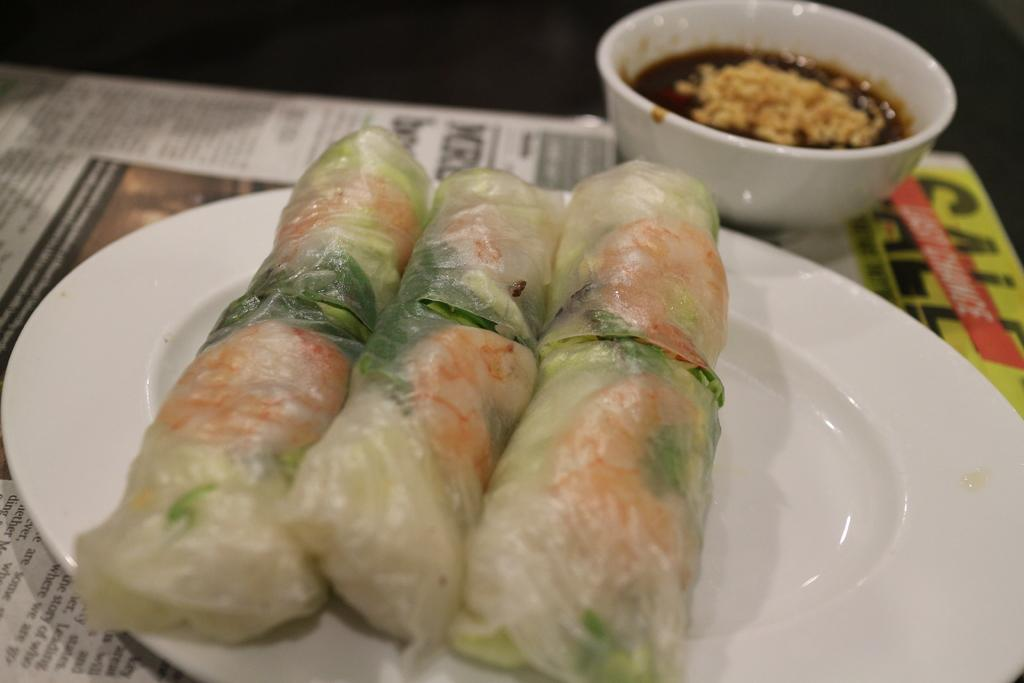What is the main food item wrapped in a cover on the plate? The facts do not specify the type of food item wrapped in a cover on the plate. What type of food is in the bowl? The facts do not specify the type of food in the bowl. What is the plate and bowl placed on? The plate and bowl are placed on a newspaper. What type of trousers can be seen in the image? There are no trousers present in the image. How did the food in the bowl burst in the image? The facts do not mention any bursting of food in the image. 